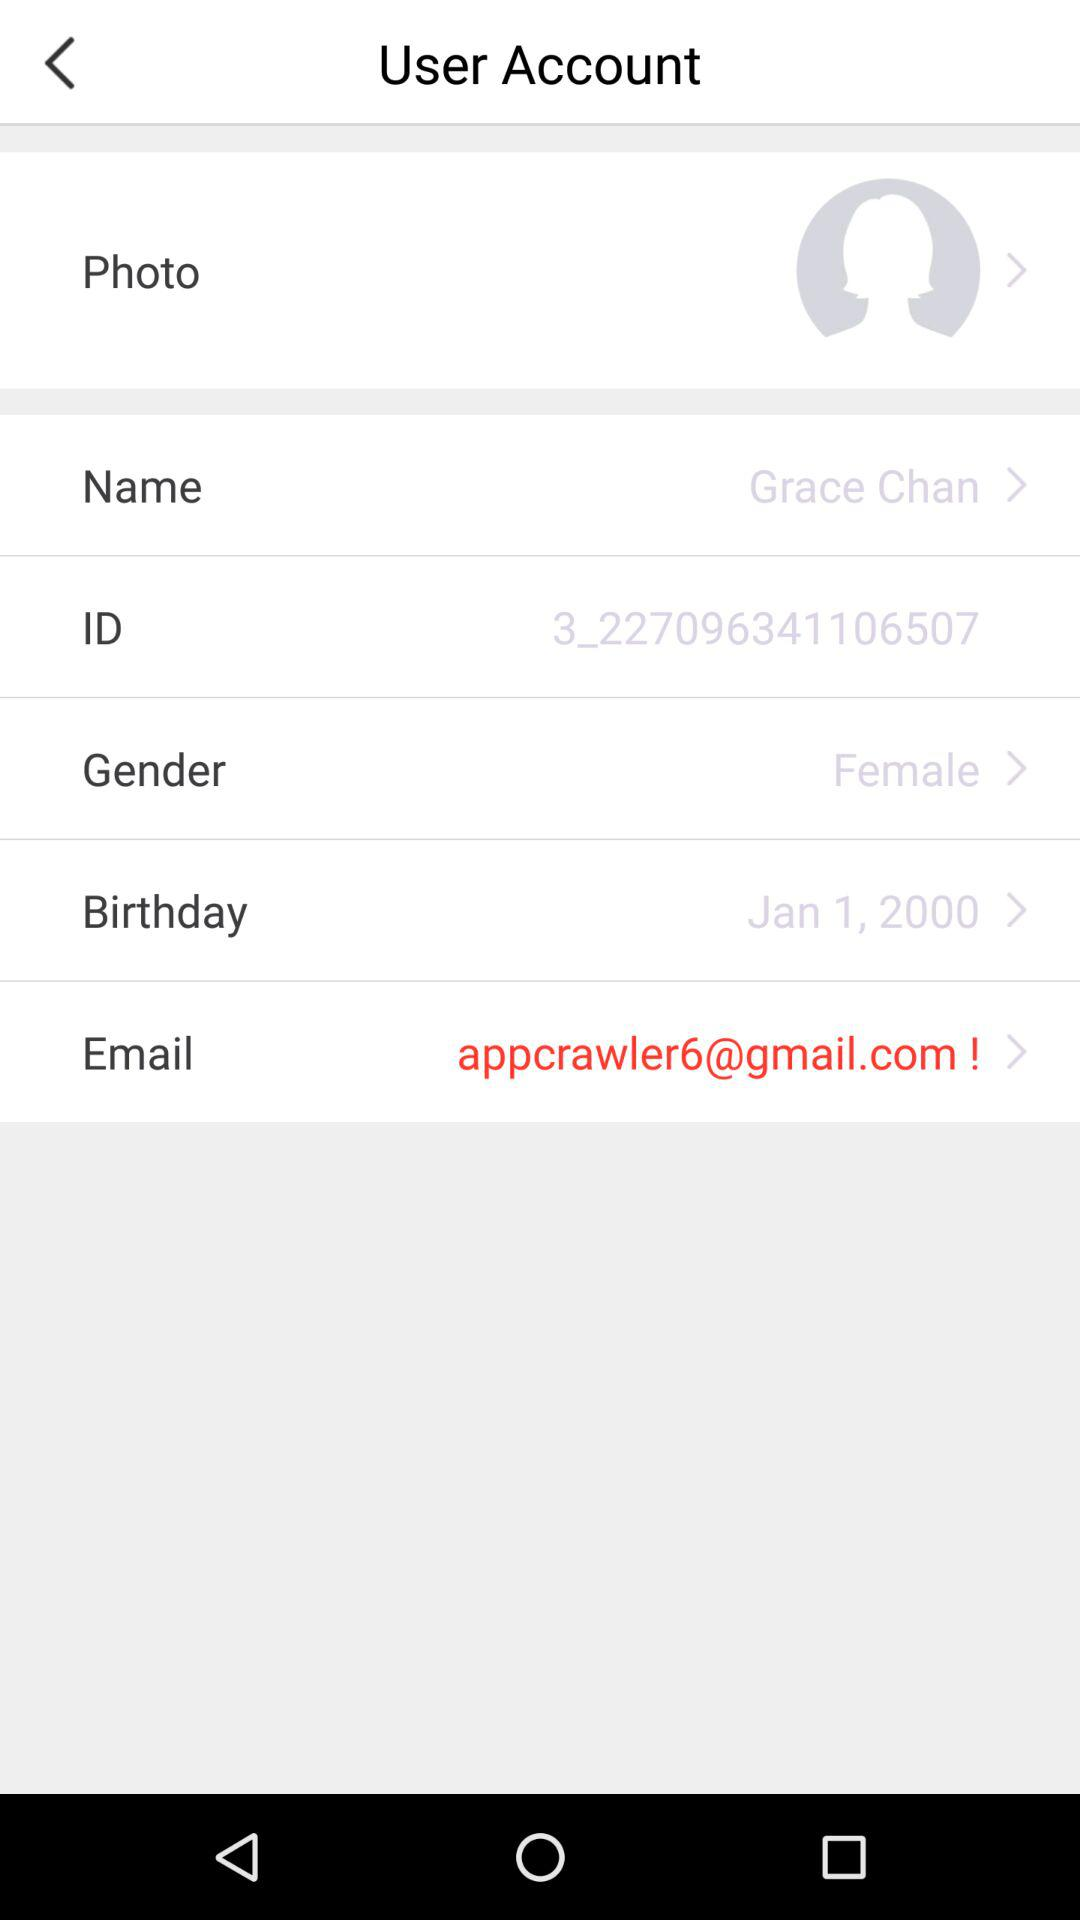What is the ID number? The ID number is 3_227096341106507. 